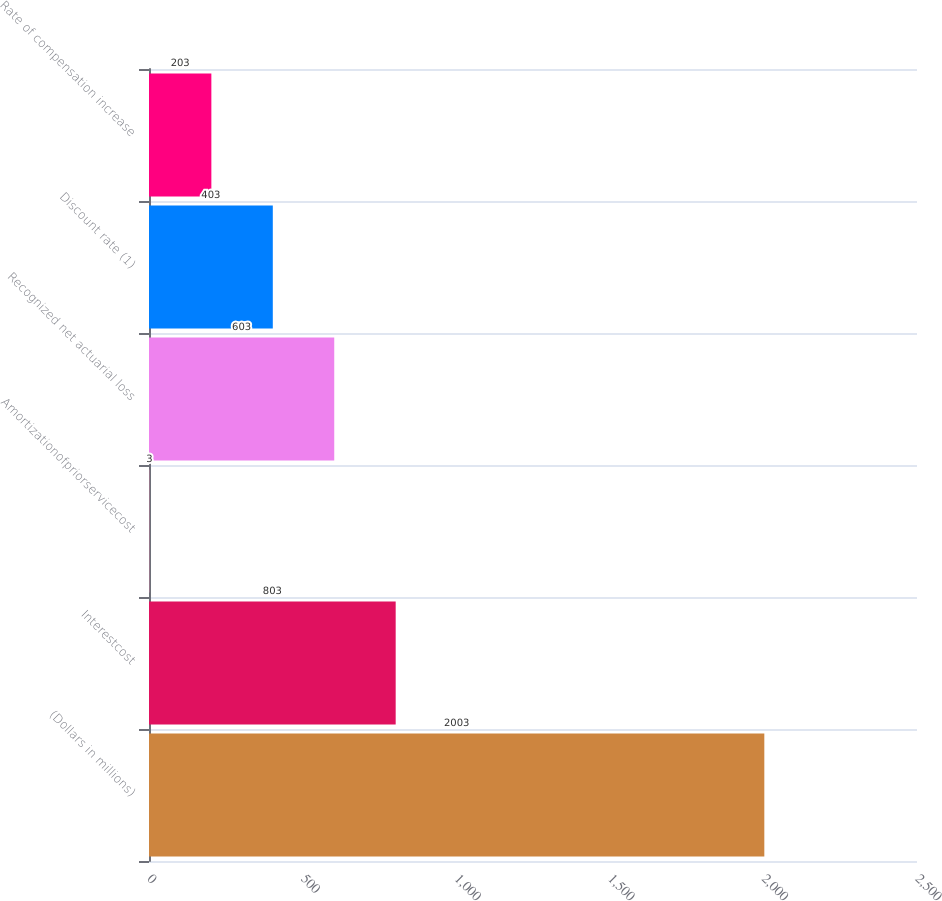<chart> <loc_0><loc_0><loc_500><loc_500><bar_chart><fcel>(Dollars in millions)<fcel>Interestcost<fcel>Amortizationofpriorservicecost<fcel>Recognized net actuarial loss<fcel>Discount rate (1)<fcel>Rate of compensation increase<nl><fcel>2003<fcel>803<fcel>3<fcel>603<fcel>403<fcel>203<nl></chart> 